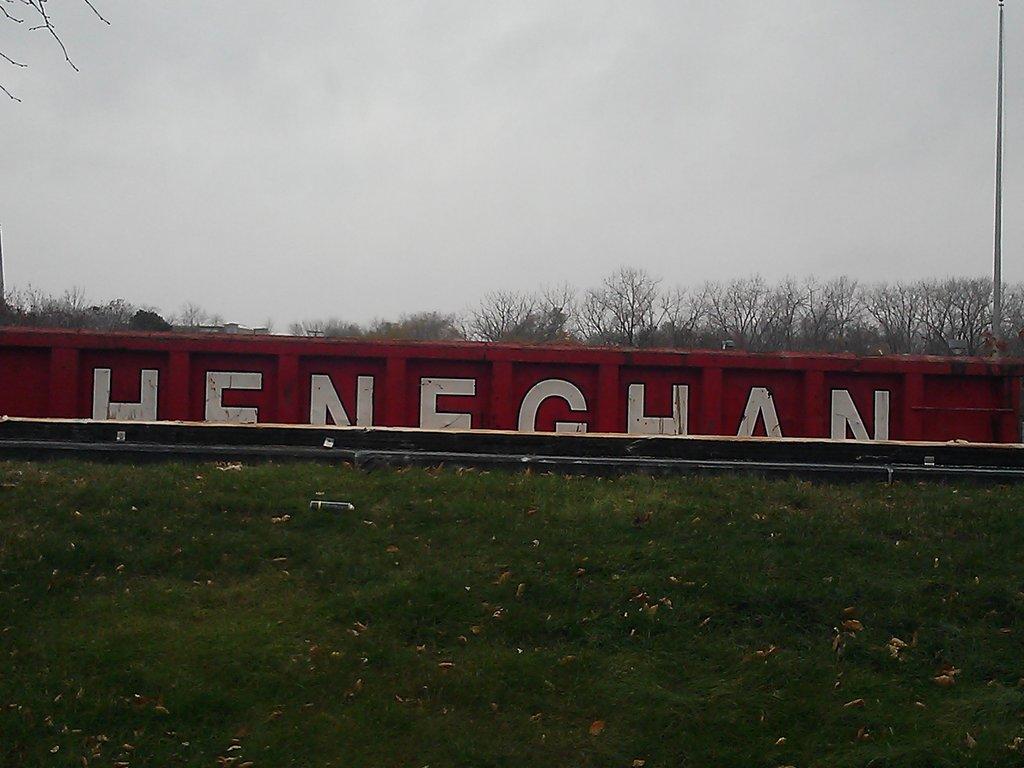What is the name on the side of the rail car?
Provide a succinct answer. Heneghan. Are the letter on the train white?
Provide a short and direct response. Yes. 